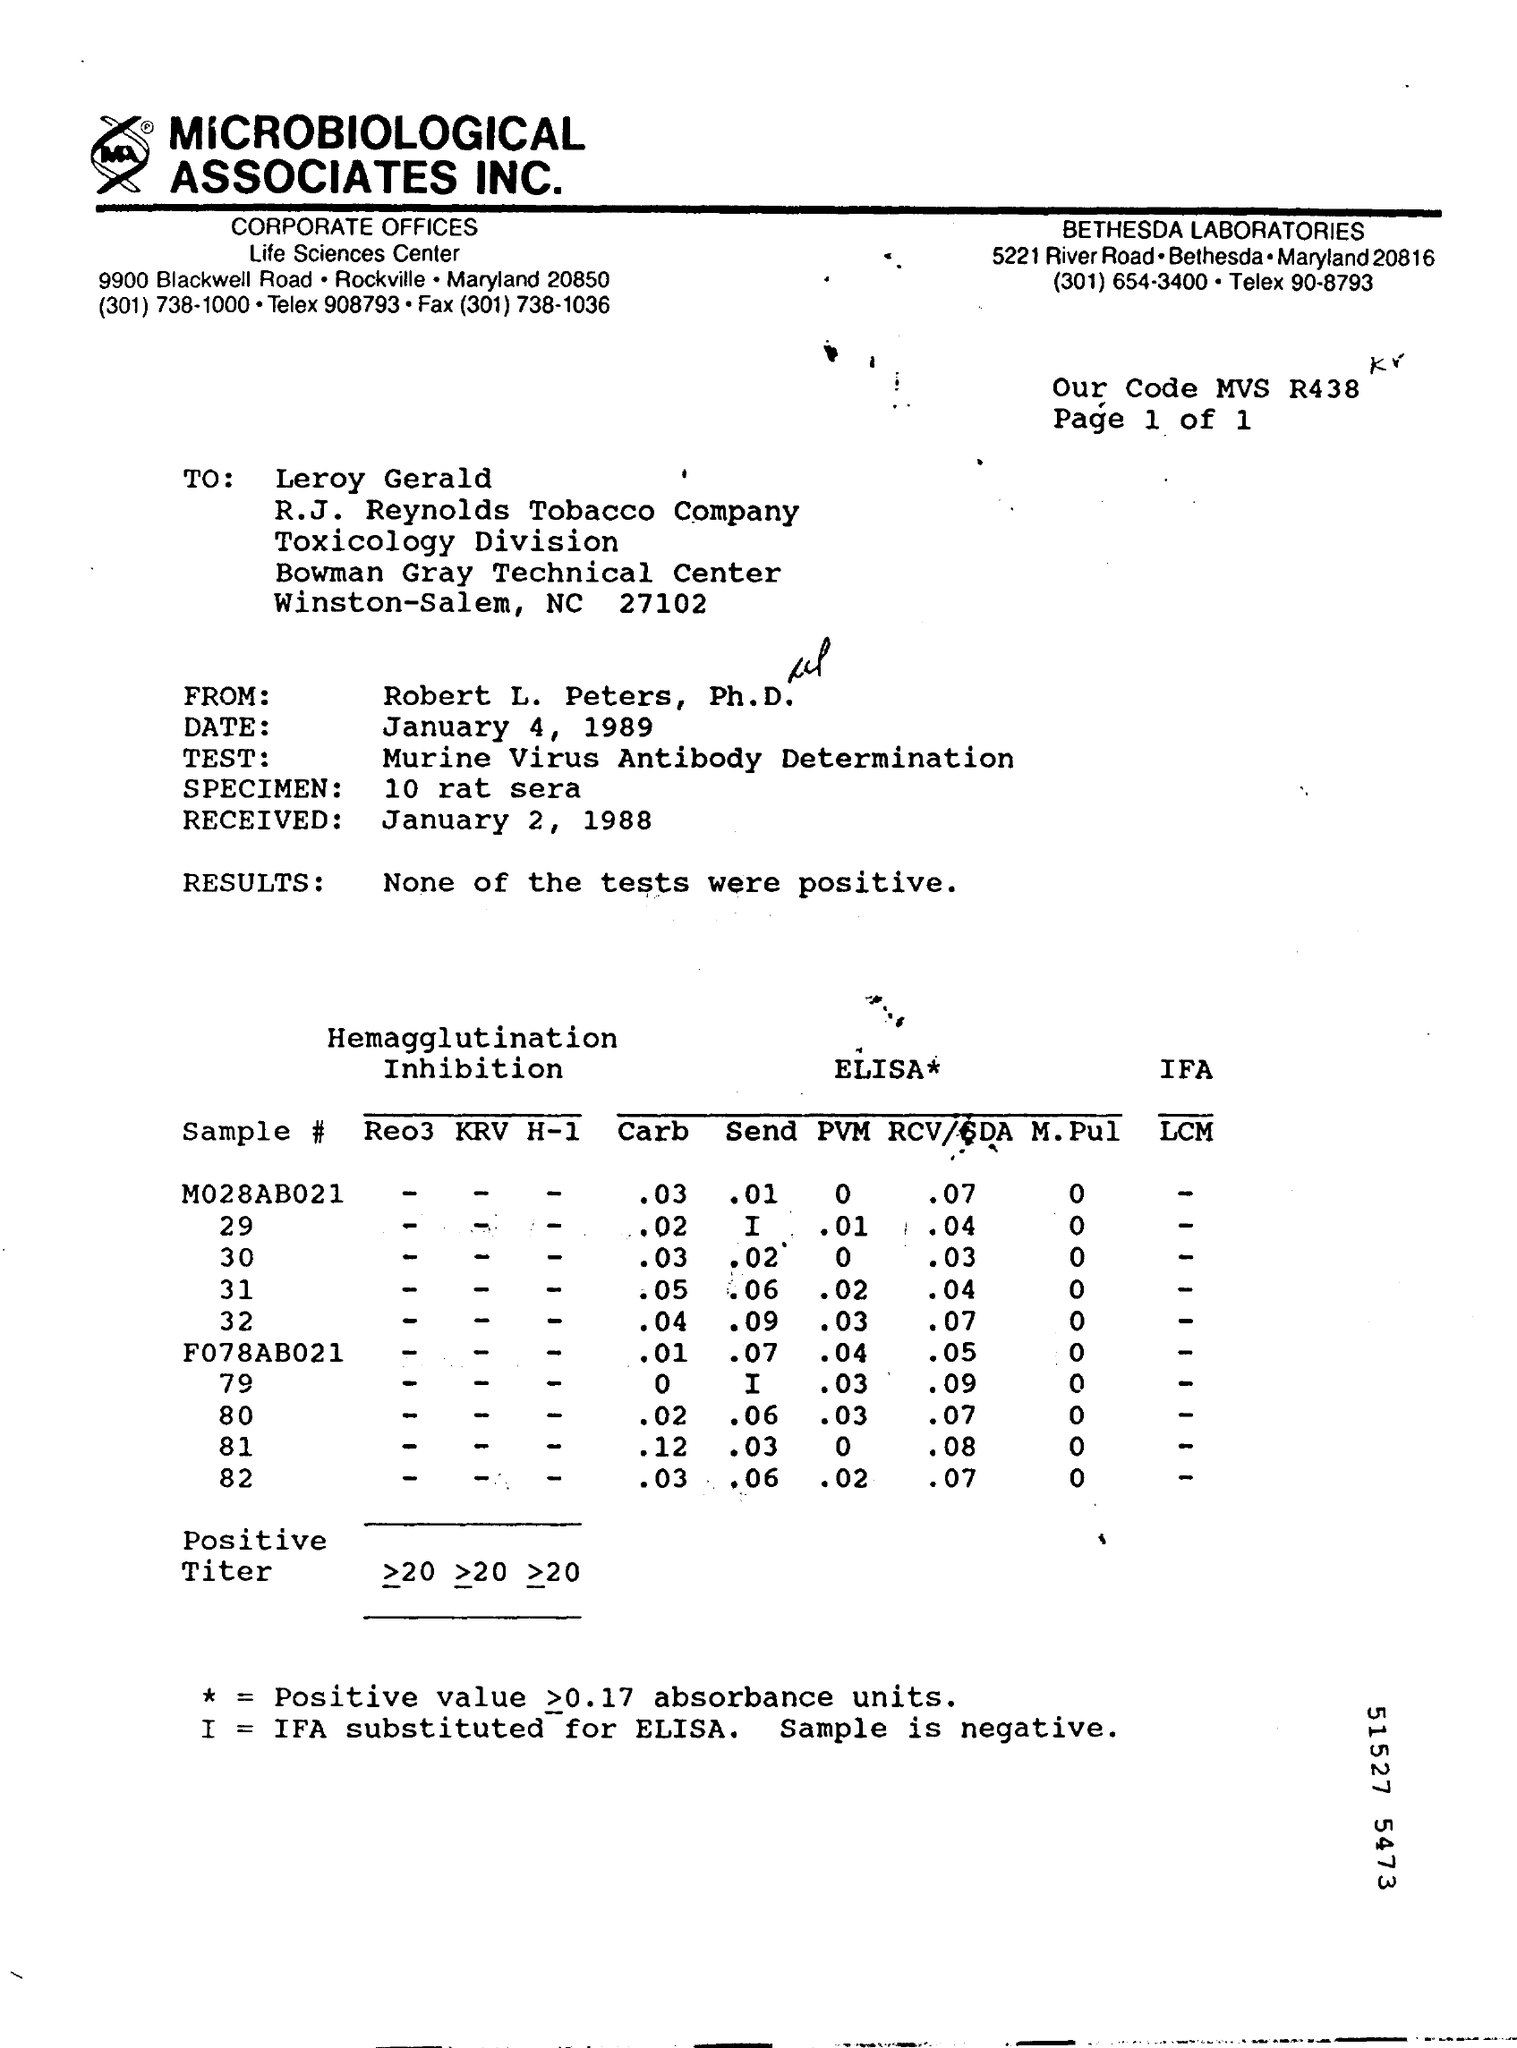To Whom this letter was sent
Provide a short and direct response. Leroy Gerald. Who is the sender of this letter
Ensure brevity in your answer.  Robert L. Peters, Ph. D. What is the Received date given in letter
Your answer should be very brief. January 2, 1988. What type of test is written in this letter
Provide a short and direct response. Murine Virus Antibody Determination. What is the Results of test given
Offer a very short reply. None of the tests were positive. 